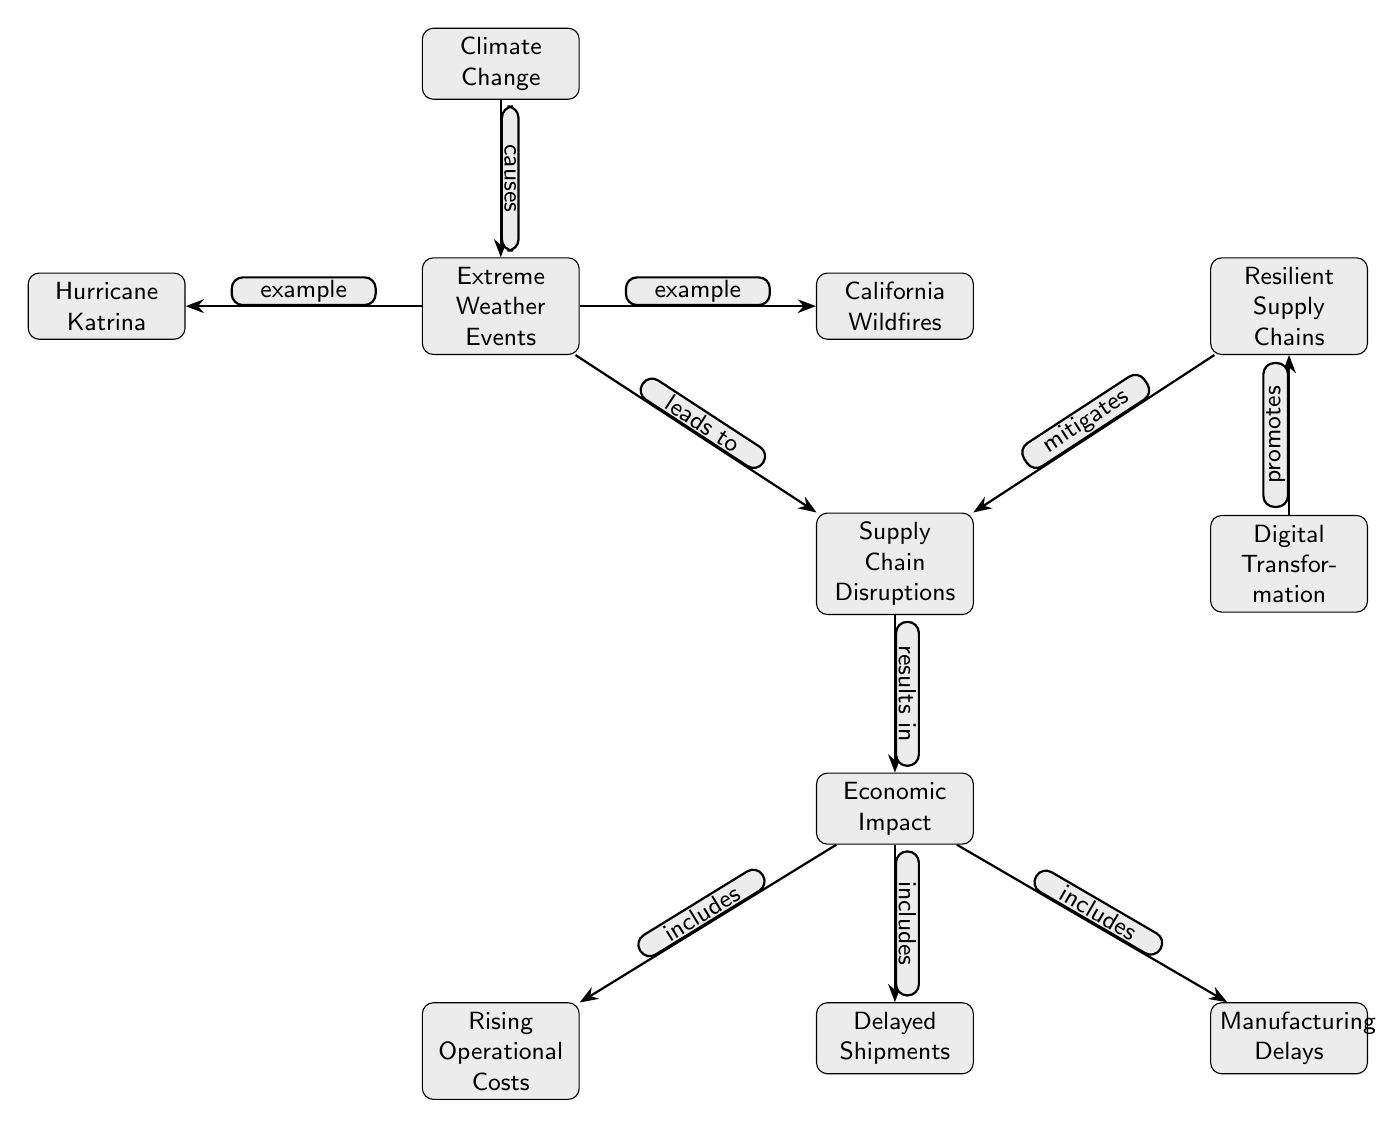What is the top node in the diagram? The top node in the diagram is "Climate Change," which is positioned at the highest point and serves as the initiating factor for the other components in the diagram.
Answer: Climate Change How many examples of extreme weather events are given? The diagram specifies two examples of extreme weather events: "Hurricane Katrina" and "California Wildfires," which are included as details connected to the "Extreme Weather Events" node.
Answer: 2 What does "Extreme Weather Events" lead to? According to the diagram, "Extreme Weather Events" directly leads to "Supply Chain Disruptions," which is indicated by an edge labeled "leads to" connecting these nodes.
Answer: Supply Chain Disruptions Which node results in increased operational costs? The "Economic Impact" node results in increased operational costs, which is shown by the edge labeled "includes" connecting "Economic Impact" to "Rising Operational Costs."
Answer: Rising Operational Costs How does Digital Transformation relate to Resilient Supply Chains? The diagram shows that "Digital Transformation" promotes "Resilient Supply Chains," as indicated by an edge labeled "promotes" connecting these two nodes, which suggests a positive influence.
Answer: Promotes What is the relationship between Supply Chain Disruptions and Economic Impact? The relationship is that "Supply Chain Disruptions" result in "Economic Impact," as denoted by an edge labeled "results in," indicating that disruptions in the supply chain directly affect the economy.
Answer: Results in How does Resilient Supply Chains affect Supply Chain Disruptions? "Resilient Supply Chains" mitigates "Supply Chain Disruptions," which is illustrated by the edge labeled "mitigates," indicating that having resilient supply chains can lessen the effects of disruptions.
Answer: Mitigates Which node is located directly below "Supply Chain Disruptions"? Beneath "Supply Chain Disruptions," directly connected below, is the "Economic Impact" node, signifying the direct consequences of the disruptions outlined above it.
Answer: Economic Impact 